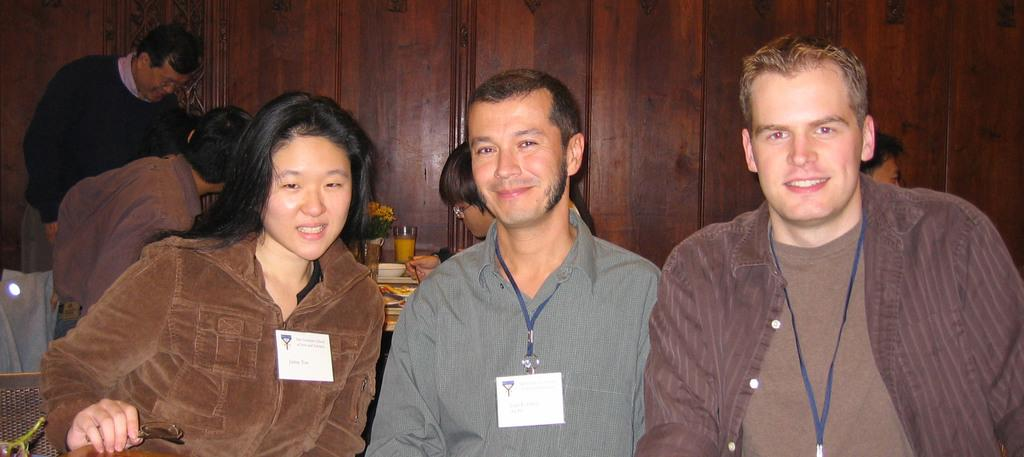What are the people in the image doing? There is a group of people sitting in the image. What can be seen on the table in the image? There is a flower vase, plates, glasses, and food items on the table in the image. Can you describe the person standing in the image? There is a person standing in the image. What type of wall is visible in the image? There is a wooden wall in the image. What is the distance between the flower vase and the person standing in the image? The provided facts do not give information about the distance between the flower vase and the person standing in the image. What type of oil is being used to cook the food items in the image? There is no information about cooking or oil in the image. Can you tell me who the father of the person standing in the image is? There is no information about family relationships in the image. 